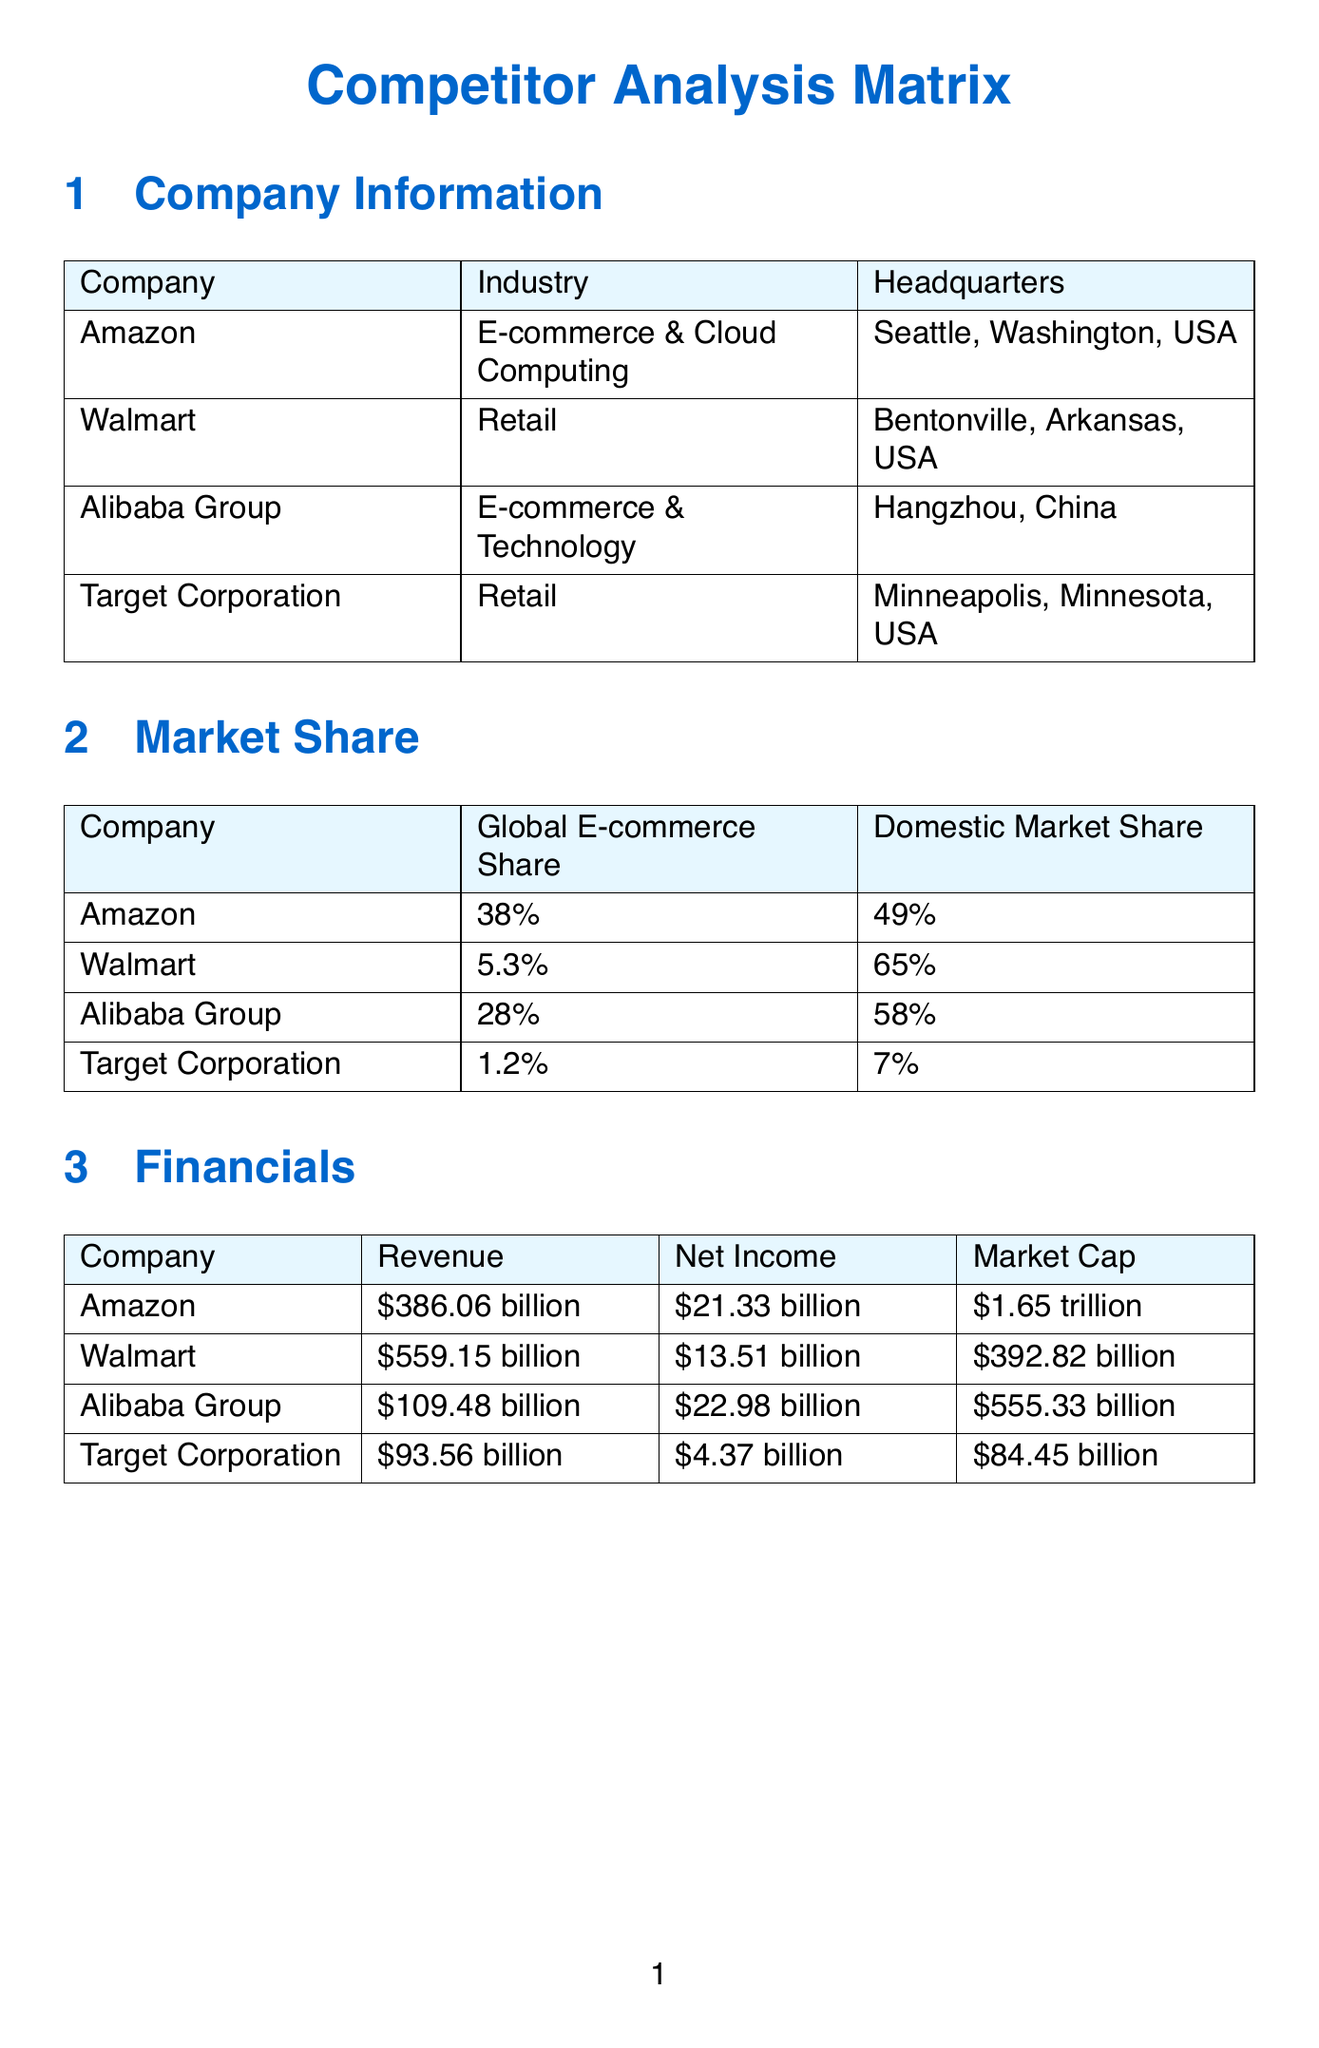What is the global e-commerce share of Amazon? This is stated in the Market Share section for each company. For Amazon, it is 38%.
Answer: 38% Which company has the highest domestic market share? The domestic market share is listed for each company. Walmart has the highest at 65%.
Answer: 65% What is Alibaba Group's projected revenue growth percentage? This information is found in the Growth Potential section for Alibaba Group. It is 30%.
Answer: 30% How much was Walmart's acquisition of Flipkart? This is noted in the Merger & Acquisition History section as the value of the acquisition. Walmart's acquisition of Flipkart was $16 billion.
Answer: $16 billion What are the four competitive advantages listed for Amazon? The advantages for each company are listed in the Competitive Advantages section. For Amazon, they include: Strong brand recognition, Extensive distribution network, AWS cloud computing leadership, Prime membership ecosystem.
Answer: Strong brand recognition, Extensive distribution network, AWS cloud computing leadership, Prime membership ecosystem Which company is headquartered in Bentonville, Arkansas, USA? The Company Information section lists headquarters for each company. Walmart is based in Bentonville, Arkansas, USA.
Answer: Walmart How many notable acquisitions did Target Corporation make? This information can be gathered from the Merger & Acquisition History section. Target Corporation made two notable acquisitions.
Answer: 2 What is the revenue of Alibaba Group? This data point can be found in the Financials section for Alibaba Group, which states the revenue as $109.48 billion.
Answer: $109.48 billion What innovation focus does Walmart have? This is detailed in the Growth Potential section for Walmart. Its innovation focus is on omnichannel retail and automated warehouses.
Answer: Omnichannel retail and automated warehouses 